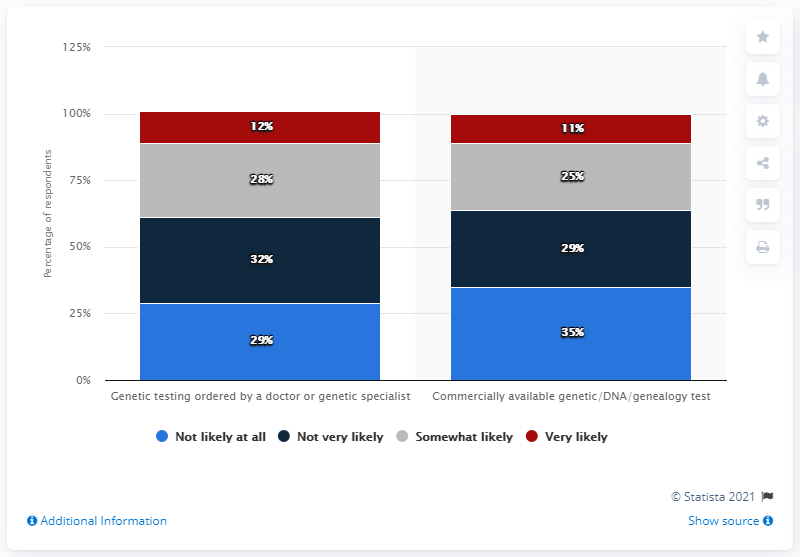Indicate a few pertinent items in this graphic. According to the data, 12% of people are very likely to use genetic testing. 